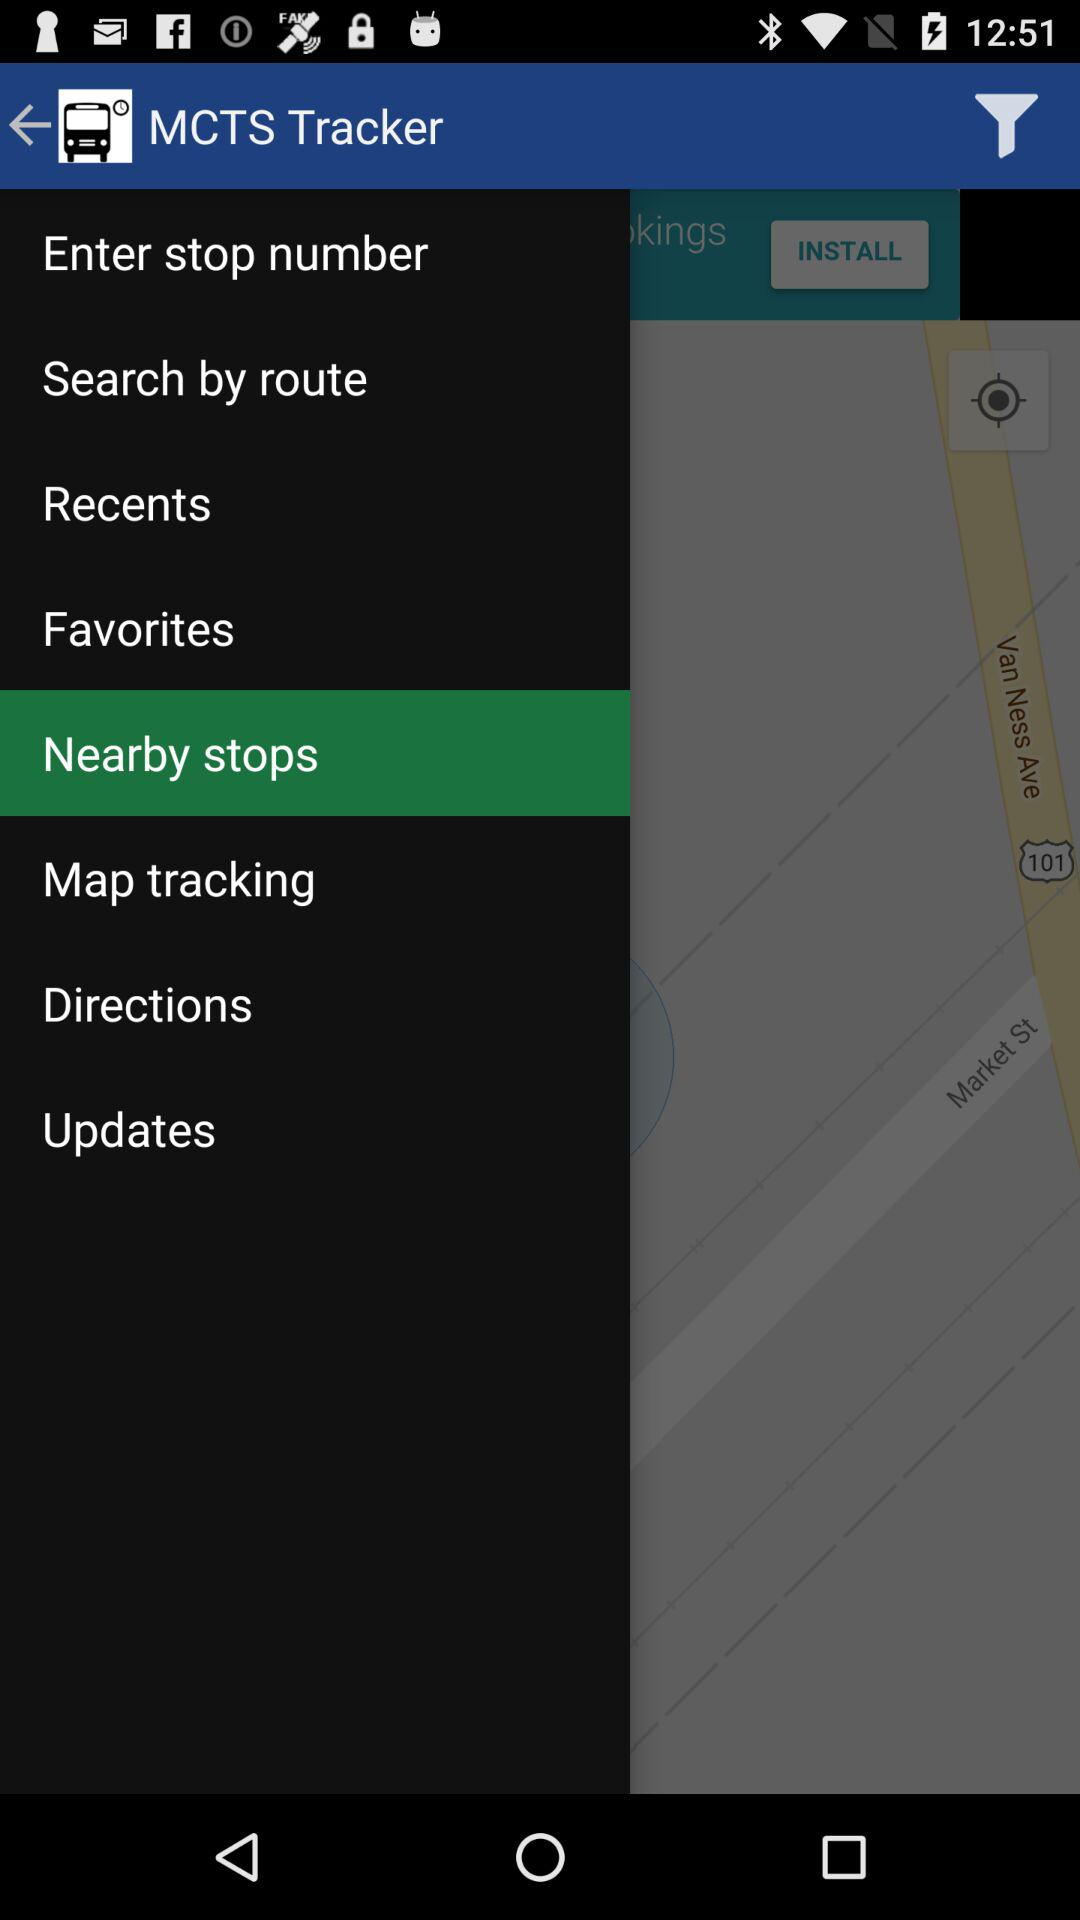Are there any updates?
When the provided information is insufficient, respond with <no answer>. <no answer> 